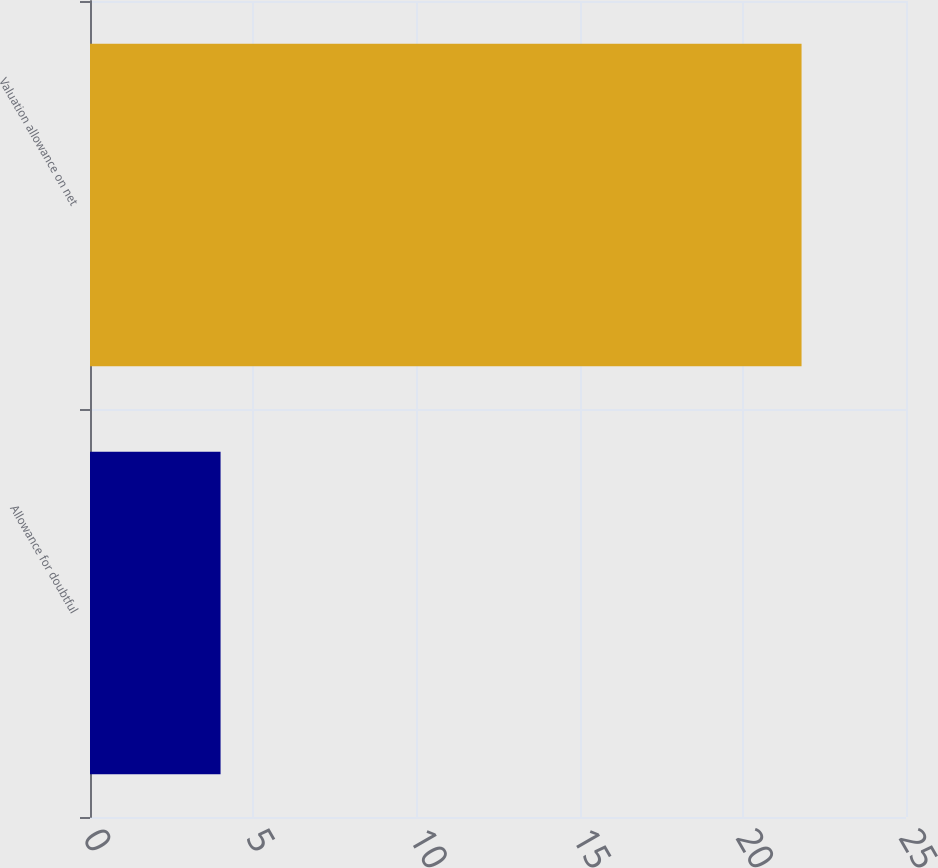<chart> <loc_0><loc_0><loc_500><loc_500><bar_chart><fcel>Allowance for doubtful<fcel>Valuation allowance on net<nl><fcel>4<fcel>21.8<nl></chart> 